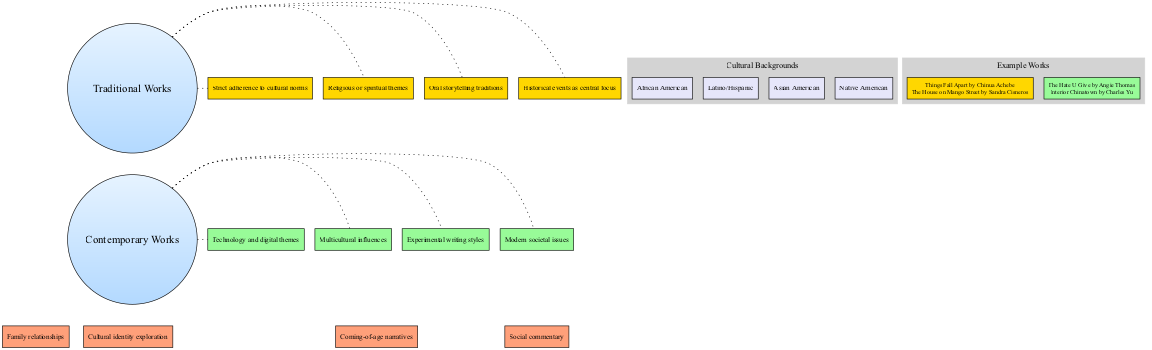What are two examples of traditional works? The diagram lists "Things Fall Apart by Chinua Achebe" and "The House on Mango Street by Sandra Cisneros" as examples of traditional works.
Answer: Things Fall Apart by Chinua Achebe, The House on Mango Street by Sandra Cisneros What themes are unique to contemporary works? The diagram indicates that contemporary works feature themes such as "Modern societal issues," "Experimental writing styles," "Multicultural influences," and "Technology and digital themes," which are not found in traditional works.
Answer: Modern societal issues, Experimental writing styles, Multicultural influences, Technology and digital themes How many cultural backgrounds are represented in the diagram? The diagram shows a total of four cultural backgrounds: African American, Latino/Hispanic, Asian American, and Native American. By counting these backgrounds, we arrive at the answer.
Answer: 4 What common theme involves personal growth? The common themes include "Cultural identity exploration," "Family relationships," "Coming-of-age narratives," and "Social commentary," with "Coming-of-age narratives" specifically addressing personal growth.
Answer: Coming-of-age narratives Which two elements are shared between traditional and contemporary works? The diagram indicates that common elements include "Cultural identity exploration," "Family relationships," "Coming-of-age narratives," and "Social commentary." Choosing any two from this list would correctly answer the question.
Answer: Cultural identity exploration, Family relationships What are two unique elements of traditional works? The diagram specifies unique elements of traditional works as "Oral storytelling traditions," "Religious or spiritual themes," "Strict adherence to cultural norms," and "Historical events as central focus." Choosing any two from this list would correctly respond to the question.
Answer: Oral storytelling traditions, Religious or spiritual themes How do contemporary works reflect societal changes? Contemporary works uniquely address "Modern societal issues," showcasing their relevance to current events and changes in society, while traditional works do not address this aspect. Therefore, the answer reflects on the modern societal issues highlighted in contemporary works.
Answer: Modern societal issues What type of relationships are discussed in both traditional and contemporary works? The common themes include "Family relationships," which appears in both traditional and contemporary works as a central focus of human experiences across cultural narratives.
Answer: Family relationships 